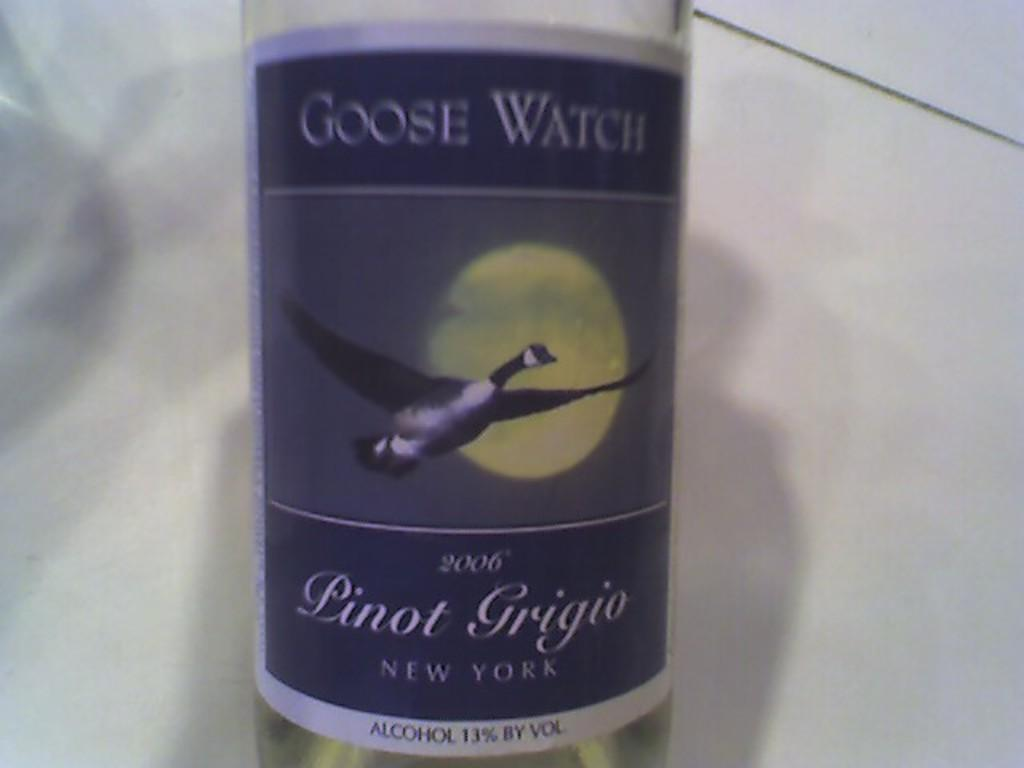<image>
Offer a succinct explanation of the picture presented. A bottle of Goose Watch Pinot Grigio sits on a white table 